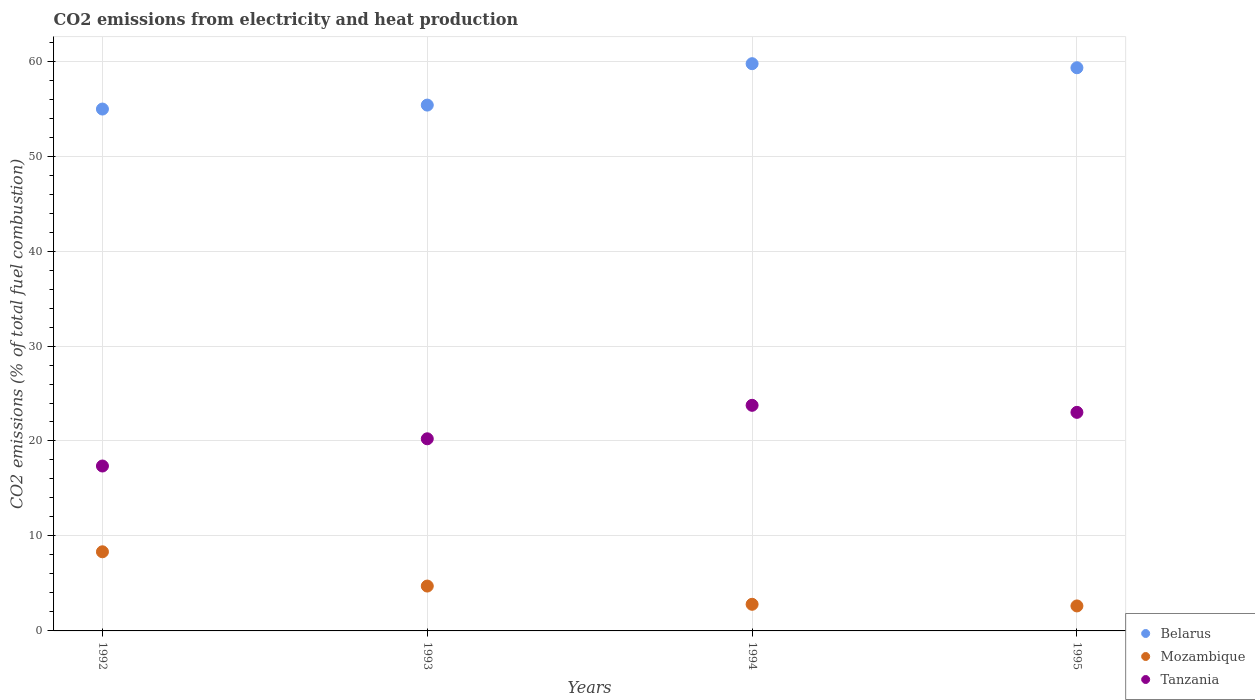How many different coloured dotlines are there?
Give a very brief answer. 3. Is the number of dotlines equal to the number of legend labels?
Your answer should be very brief. Yes. What is the amount of CO2 emitted in Tanzania in 1992?
Offer a terse response. 17.37. Across all years, what is the maximum amount of CO2 emitted in Belarus?
Make the answer very short. 59.73. Across all years, what is the minimum amount of CO2 emitted in Tanzania?
Give a very brief answer. 17.37. What is the total amount of CO2 emitted in Tanzania in the graph?
Keep it short and to the point. 84.37. What is the difference between the amount of CO2 emitted in Mozambique in 1994 and that in 1995?
Ensure brevity in your answer.  0.17. What is the difference between the amount of CO2 emitted in Mozambique in 1992 and the amount of CO2 emitted in Tanzania in 1994?
Your answer should be very brief. -15.42. What is the average amount of CO2 emitted in Belarus per year?
Give a very brief answer. 57.34. In the year 1995, what is the difference between the amount of CO2 emitted in Tanzania and amount of CO2 emitted in Mozambique?
Make the answer very short. 20.38. In how many years, is the amount of CO2 emitted in Tanzania greater than 52 %?
Make the answer very short. 0. What is the ratio of the amount of CO2 emitted in Mozambique in 1992 to that in 1994?
Ensure brevity in your answer.  2.97. Is the amount of CO2 emitted in Tanzania in 1992 less than that in 1995?
Keep it short and to the point. Yes. Is the difference between the amount of CO2 emitted in Tanzania in 1992 and 1995 greater than the difference between the amount of CO2 emitted in Mozambique in 1992 and 1995?
Provide a succinct answer. No. What is the difference between the highest and the second highest amount of CO2 emitted in Mozambique?
Ensure brevity in your answer.  3.61. What is the difference between the highest and the lowest amount of CO2 emitted in Mozambique?
Your answer should be compact. 5.7. In how many years, is the amount of CO2 emitted in Belarus greater than the average amount of CO2 emitted in Belarus taken over all years?
Offer a very short reply. 2. Is the sum of the amount of CO2 emitted in Tanzania in 1993 and 1994 greater than the maximum amount of CO2 emitted in Belarus across all years?
Make the answer very short. No. Is it the case that in every year, the sum of the amount of CO2 emitted in Tanzania and amount of CO2 emitted in Mozambique  is greater than the amount of CO2 emitted in Belarus?
Your answer should be very brief. No. How many years are there in the graph?
Your response must be concise. 4. Are the values on the major ticks of Y-axis written in scientific E-notation?
Your answer should be compact. No. Does the graph contain grids?
Your answer should be compact. Yes. How are the legend labels stacked?
Ensure brevity in your answer.  Vertical. What is the title of the graph?
Give a very brief answer. CO2 emissions from electricity and heat production. What is the label or title of the X-axis?
Give a very brief answer. Years. What is the label or title of the Y-axis?
Make the answer very short. CO2 emissions (% of total fuel combustion). What is the CO2 emissions (% of total fuel combustion) in Belarus in 1992?
Offer a terse response. 54.95. What is the CO2 emissions (% of total fuel combustion) in Mozambique in 1992?
Make the answer very short. 8.33. What is the CO2 emissions (% of total fuel combustion) of Tanzania in 1992?
Provide a succinct answer. 17.37. What is the CO2 emissions (% of total fuel combustion) in Belarus in 1993?
Offer a very short reply. 55.37. What is the CO2 emissions (% of total fuel combustion) in Mozambique in 1993?
Ensure brevity in your answer.  4.72. What is the CO2 emissions (% of total fuel combustion) of Tanzania in 1993?
Your response must be concise. 20.23. What is the CO2 emissions (% of total fuel combustion) of Belarus in 1994?
Your answer should be compact. 59.73. What is the CO2 emissions (% of total fuel combustion) in Mozambique in 1994?
Offer a terse response. 2.8. What is the CO2 emissions (% of total fuel combustion) of Tanzania in 1994?
Make the answer very short. 23.76. What is the CO2 emissions (% of total fuel combustion) of Belarus in 1995?
Your answer should be very brief. 59.3. What is the CO2 emissions (% of total fuel combustion) of Mozambique in 1995?
Provide a short and direct response. 2.63. What is the CO2 emissions (% of total fuel combustion) in Tanzania in 1995?
Your response must be concise. 23.02. Across all years, what is the maximum CO2 emissions (% of total fuel combustion) of Belarus?
Give a very brief answer. 59.73. Across all years, what is the maximum CO2 emissions (% of total fuel combustion) of Mozambique?
Make the answer very short. 8.33. Across all years, what is the maximum CO2 emissions (% of total fuel combustion) of Tanzania?
Keep it short and to the point. 23.76. Across all years, what is the minimum CO2 emissions (% of total fuel combustion) in Belarus?
Give a very brief answer. 54.95. Across all years, what is the minimum CO2 emissions (% of total fuel combustion) in Mozambique?
Provide a short and direct response. 2.63. Across all years, what is the minimum CO2 emissions (% of total fuel combustion) of Tanzania?
Provide a succinct answer. 17.37. What is the total CO2 emissions (% of total fuel combustion) in Belarus in the graph?
Provide a succinct answer. 229.36. What is the total CO2 emissions (% of total fuel combustion) of Mozambique in the graph?
Ensure brevity in your answer.  18.49. What is the total CO2 emissions (% of total fuel combustion) of Tanzania in the graph?
Make the answer very short. 84.37. What is the difference between the CO2 emissions (% of total fuel combustion) in Belarus in 1992 and that in 1993?
Give a very brief answer. -0.42. What is the difference between the CO2 emissions (% of total fuel combustion) in Mozambique in 1992 and that in 1993?
Provide a short and direct response. 3.61. What is the difference between the CO2 emissions (% of total fuel combustion) in Tanzania in 1992 and that in 1993?
Your answer should be very brief. -2.87. What is the difference between the CO2 emissions (% of total fuel combustion) of Belarus in 1992 and that in 1994?
Keep it short and to the point. -4.78. What is the difference between the CO2 emissions (% of total fuel combustion) of Mozambique in 1992 and that in 1994?
Your response must be concise. 5.53. What is the difference between the CO2 emissions (% of total fuel combustion) of Tanzania in 1992 and that in 1994?
Offer a terse response. -6.39. What is the difference between the CO2 emissions (% of total fuel combustion) of Belarus in 1992 and that in 1995?
Provide a short and direct response. -4.35. What is the difference between the CO2 emissions (% of total fuel combustion) in Mozambique in 1992 and that in 1995?
Provide a short and direct response. 5.7. What is the difference between the CO2 emissions (% of total fuel combustion) of Tanzania in 1992 and that in 1995?
Offer a terse response. -5.65. What is the difference between the CO2 emissions (% of total fuel combustion) of Belarus in 1993 and that in 1994?
Make the answer very short. -4.36. What is the difference between the CO2 emissions (% of total fuel combustion) of Mozambique in 1993 and that in 1994?
Your answer should be very brief. 1.92. What is the difference between the CO2 emissions (% of total fuel combustion) in Tanzania in 1993 and that in 1994?
Provide a short and direct response. -3.53. What is the difference between the CO2 emissions (% of total fuel combustion) in Belarus in 1993 and that in 1995?
Make the answer very short. -3.93. What is the difference between the CO2 emissions (% of total fuel combustion) of Mozambique in 1993 and that in 1995?
Ensure brevity in your answer.  2.09. What is the difference between the CO2 emissions (% of total fuel combustion) of Tanzania in 1993 and that in 1995?
Ensure brevity in your answer.  -2.78. What is the difference between the CO2 emissions (% of total fuel combustion) of Belarus in 1994 and that in 1995?
Offer a very short reply. 0.43. What is the difference between the CO2 emissions (% of total fuel combustion) of Mozambique in 1994 and that in 1995?
Your response must be concise. 0.17. What is the difference between the CO2 emissions (% of total fuel combustion) of Tanzania in 1994 and that in 1995?
Your answer should be compact. 0.74. What is the difference between the CO2 emissions (% of total fuel combustion) of Belarus in 1992 and the CO2 emissions (% of total fuel combustion) of Mozambique in 1993?
Make the answer very short. 50.23. What is the difference between the CO2 emissions (% of total fuel combustion) of Belarus in 1992 and the CO2 emissions (% of total fuel combustion) of Tanzania in 1993?
Provide a short and direct response. 34.72. What is the difference between the CO2 emissions (% of total fuel combustion) of Mozambique in 1992 and the CO2 emissions (% of total fuel combustion) of Tanzania in 1993?
Offer a terse response. -11.9. What is the difference between the CO2 emissions (% of total fuel combustion) of Belarus in 1992 and the CO2 emissions (% of total fuel combustion) of Mozambique in 1994?
Ensure brevity in your answer.  52.15. What is the difference between the CO2 emissions (% of total fuel combustion) in Belarus in 1992 and the CO2 emissions (% of total fuel combustion) in Tanzania in 1994?
Your response must be concise. 31.2. What is the difference between the CO2 emissions (% of total fuel combustion) in Mozambique in 1992 and the CO2 emissions (% of total fuel combustion) in Tanzania in 1994?
Keep it short and to the point. -15.42. What is the difference between the CO2 emissions (% of total fuel combustion) of Belarus in 1992 and the CO2 emissions (% of total fuel combustion) of Mozambique in 1995?
Ensure brevity in your answer.  52.32. What is the difference between the CO2 emissions (% of total fuel combustion) in Belarus in 1992 and the CO2 emissions (% of total fuel combustion) in Tanzania in 1995?
Your answer should be very brief. 31.94. What is the difference between the CO2 emissions (% of total fuel combustion) of Mozambique in 1992 and the CO2 emissions (% of total fuel combustion) of Tanzania in 1995?
Offer a very short reply. -14.68. What is the difference between the CO2 emissions (% of total fuel combustion) in Belarus in 1993 and the CO2 emissions (% of total fuel combustion) in Mozambique in 1994?
Ensure brevity in your answer.  52.57. What is the difference between the CO2 emissions (% of total fuel combustion) in Belarus in 1993 and the CO2 emissions (% of total fuel combustion) in Tanzania in 1994?
Offer a very short reply. 31.61. What is the difference between the CO2 emissions (% of total fuel combustion) of Mozambique in 1993 and the CO2 emissions (% of total fuel combustion) of Tanzania in 1994?
Your response must be concise. -19.03. What is the difference between the CO2 emissions (% of total fuel combustion) in Belarus in 1993 and the CO2 emissions (% of total fuel combustion) in Mozambique in 1995?
Keep it short and to the point. 52.74. What is the difference between the CO2 emissions (% of total fuel combustion) of Belarus in 1993 and the CO2 emissions (% of total fuel combustion) of Tanzania in 1995?
Your response must be concise. 32.36. What is the difference between the CO2 emissions (% of total fuel combustion) in Mozambique in 1993 and the CO2 emissions (% of total fuel combustion) in Tanzania in 1995?
Your answer should be very brief. -18.29. What is the difference between the CO2 emissions (% of total fuel combustion) in Belarus in 1994 and the CO2 emissions (% of total fuel combustion) in Mozambique in 1995?
Offer a very short reply. 57.1. What is the difference between the CO2 emissions (% of total fuel combustion) of Belarus in 1994 and the CO2 emissions (% of total fuel combustion) of Tanzania in 1995?
Your answer should be compact. 36.71. What is the difference between the CO2 emissions (% of total fuel combustion) in Mozambique in 1994 and the CO2 emissions (% of total fuel combustion) in Tanzania in 1995?
Keep it short and to the point. -20.21. What is the average CO2 emissions (% of total fuel combustion) of Belarus per year?
Your answer should be very brief. 57.34. What is the average CO2 emissions (% of total fuel combustion) in Mozambique per year?
Your response must be concise. 4.62. What is the average CO2 emissions (% of total fuel combustion) in Tanzania per year?
Ensure brevity in your answer.  21.09. In the year 1992, what is the difference between the CO2 emissions (% of total fuel combustion) of Belarus and CO2 emissions (% of total fuel combustion) of Mozambique?
Ensure brevity in your answer.  46.62. In the year 1992, what is the difference between the CO2 emissions (% of total fuel combustion) in Belarus and CO2 emissions (% of total fuel combustion) in Tanzania?
Make the answer very short. 37.59. In the year 1992, what is the difference between the CO2 emissions (% of total fuel combustion) of Mozambique and CO2 emissions (% of total fuel combustion) of Tanzania?
Provide a succinct answer. -9.03. In the year 1993, what is the difference between the CO2 emissions (% of total fuel combustion) in Belarus and CO2 emissions (% of total fuel combustion) in Mozambique?
Offer a very short reply. 50.65. In the year 1993, what is the difference between the CO2 emissions (% of total fuel combustion) in Belarus and CO2 emissions (% of total fuel combustion) in Tanzania?
Your response must be concise. 35.14. In the year 1993, what is the difference between the CO2 emissions (% of total fuel combustion) of Mozambique and CO2 emissions (% of total fuel combustion) of Tanzania?
Keep it short and to the point. -15.51. In the year 1994, what is the difference between the CO2 emissions (% of total fuel combustion) in Belarus and CO2 emissions (% of total fuel combustion) in Mozambique?
Your response must be concise. 56.93. In the year 1994, what is the difference between the CO2 emissions (% of total fuel combustion) in Belarus and CO2 emissions (% of total fuel combustion) in Tanzania?
Give a very brief answer. 35.97. In the year 1994, what is the difference between the CO2 emissions (% of total fuel combustion) in Mozambique and CO2 emissions (% of total fuel combustion) in Tanzania?
Ensure brevity in your answer.  -20.95. In the year 1995, what is the difference between the CO2 emissions (% of total fuel combustion) of Belarus and CO2 emissions (% of total fuel combustion) of Mozambique?
Ensure brevity in your answer.  56.67. In the year 1995, what is the difference between the CO2 emissions (% of total fuel combustion) in Belarus and CO2 emissions (% of total fuel combustion) in Tanzania?
Provide a succinct answer. 36.29. In the year 1995, what is the difference between the CO2 emissions (% of total fuel combustion) of Mozambique and CO2 emissions (% of total fuel combustion) of Tanzania?
Keep it short and to the point. -20.38. What is the ratio of the CO2 emissions (% of total fuel combustion) in Belarus in 1992 to that in 1993?
Ensure brevity in your answer.  0.99. What is the ratio of the CO2 emissions (% of total fuel combustion) in Mozambique in 1992 to that in 1993?
Provide a short and direct response. 1.76. What is the ratio of the CO2 emissions (% of total fuel combustion) of Tanzania in 1992 to that in 1993?
Your response must be concise. 0.86. What is the ratio of the CO2 emissions (% of total fuel combustion) of Belarus in 1992 to that in 1994?
Offer a terse response. 0.92. What is the ratio of the CO2 emissions (% of total fuel combustion) in Mozambique in 1992 to that in 1994?
Your answer should be very brief. 2.97. What is the ratio of the CO2 emissions (% of total fuel combustion) in Tanzania in 1992 to that in 1994?
Give a very brief answer. 0.73. What is the ratio of the CO2 emissions (% of total fuel combustion) of Belarus in 1992 to that in 1995?
Give a very brief answer. 0.93. What is the ratio of the CO2 emissions (% of total fuel combustion) of Mozambique in 1992 to that in 1995?
Provide a succinct answer. 3.17. What is the ratio of the CO2 emissions (% of total fuel combustion) of Tanzania in 1992 to that in 1995?
Offer a terse response. 0.75. What is the ratio of the CO2 emissions (% of total fuel combustion) in Belarus in 1993 to that in 1994?
Keep it short and to the point. 0.93. What is the ratio of the CO2 emissions (% of total fuel combustion) in Mozambique in 1993 to that in 1994?
Give a very brief answer. 1.69. What is the ratio of the CO2 emissions (% of total fuel combustion) of Tanzania in 1993 to that in 1994?
Offer a very short reply. 0.85. What is the ratio of the CO2 emissions (% of total fuel combustion) of Belarus in 1993 to that in 1995?
Your answer should be very brief. 0.93. What is the ratio of the CO2 emissions (% of total fuel combustion) in Mozambique in 1993 to that in 1995?
Your answer should be very brief. 1.8. What is the ratio of the CO2 emissions (% of total fuel combustion) of Tanzania in 1993 to that in 1995?
Provide a succinct answer. 0.88. What is the ratio of the CO2 emissions (% of total fuel combustion) of Mozambique in 1994 to that in 1995?
Ensure brevity in your answer.  1.07. What is the ratio of the CO2 emissions (% of total fuel combustion) of Tanzania in 1994 to that in 1995?
Your answer should be very brief. 1.03. What is the difference between the highest and the second highest CO2 emissions (% of total fuel combustion) of Belarus?
Give a very brief answer. 0.43. What is the difference between the highest and the second highest CO2 emissions (% of total fuel combustion) in Mozambique?
Offer a terse response. 3.61. What is the difference between the highest and the second highest CO2 emissions (% of total fuel combustion) of Tanzania?
Your answer should be very brief. 0.74. What is the difference between the highest and the lowest CO2 emissions (% of total fuel combustion) in Belarus?
Your answer should be compact. 4.78. What is the difference between the highest and the lowest CO2 emissions (% of total fuel combustion) in Mozambique?
Keep it short and to the point. 5.7. What is the difference between the highest and the lowest CO2 emissions (% of total fuel combustion) in Tanzania?
Offer a terse response. 6.39. 